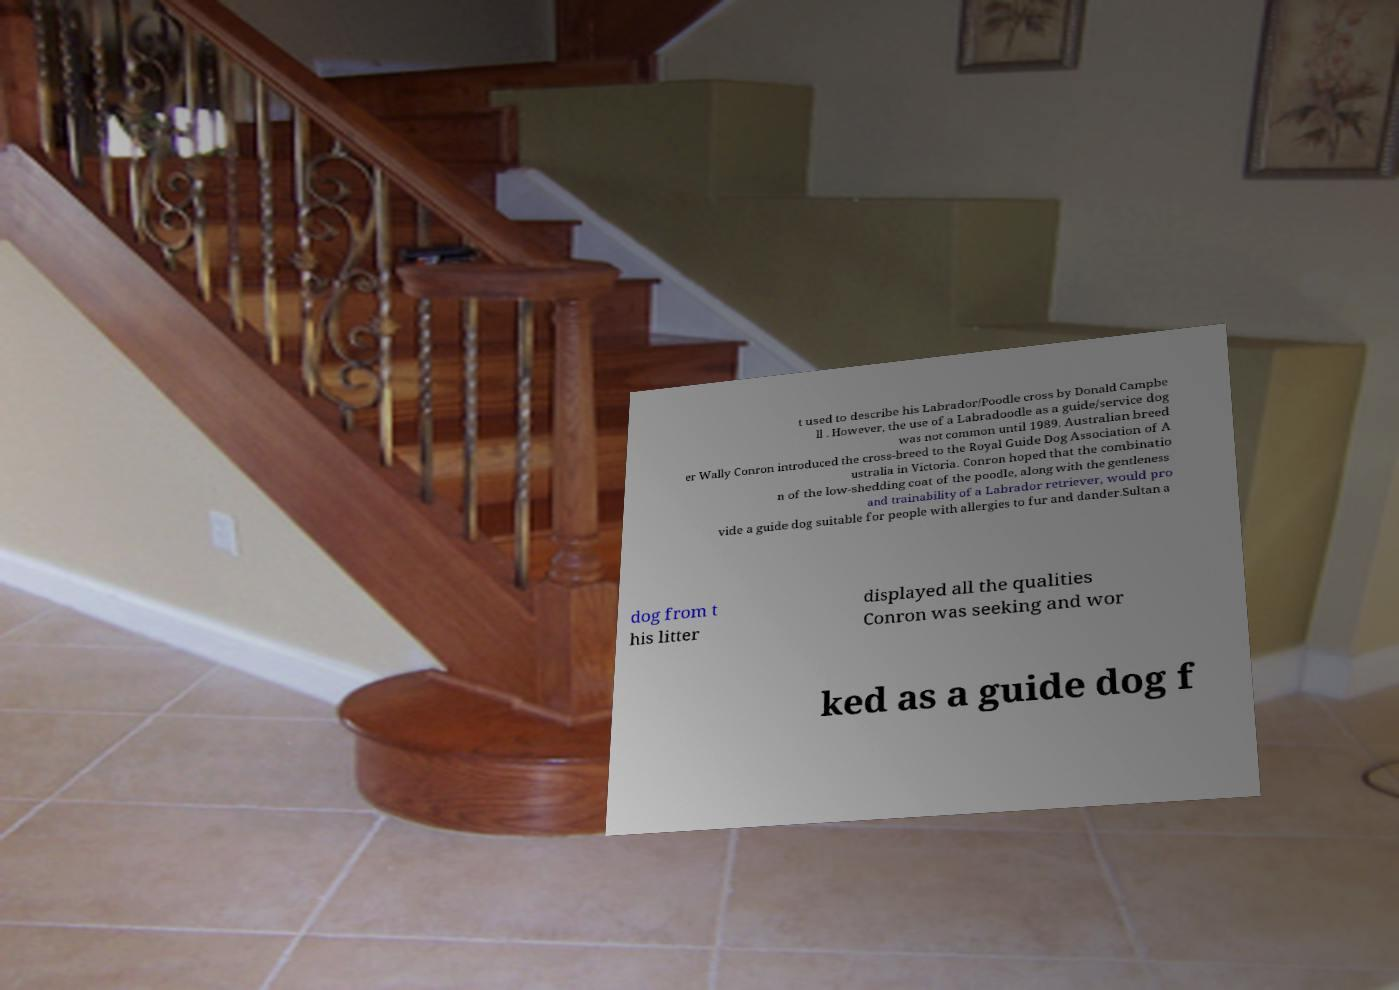What messages or text are displayed in this image? I need them in a readable, typed format. t used to describe his Labrador/Poodle cross by Donald Campbe ll . However, the use of a Labradoodle as a guide/service dog was not common until 1989. Australian breed er Wally Conron introduced the cross-breed to the Royal Guide Dog Association of A ustralia in Victoria. Conron hoped that the combinatio n of the low-shedding coat of the poodle, along with the gentleness and trainability of a Labrador retriever, would pro vide a guide dog suitable for people with allergies to fur and dander.Sultan a dog from t his litter displayed all the qualities Conron was seeking and wor ked as a guide dog f 